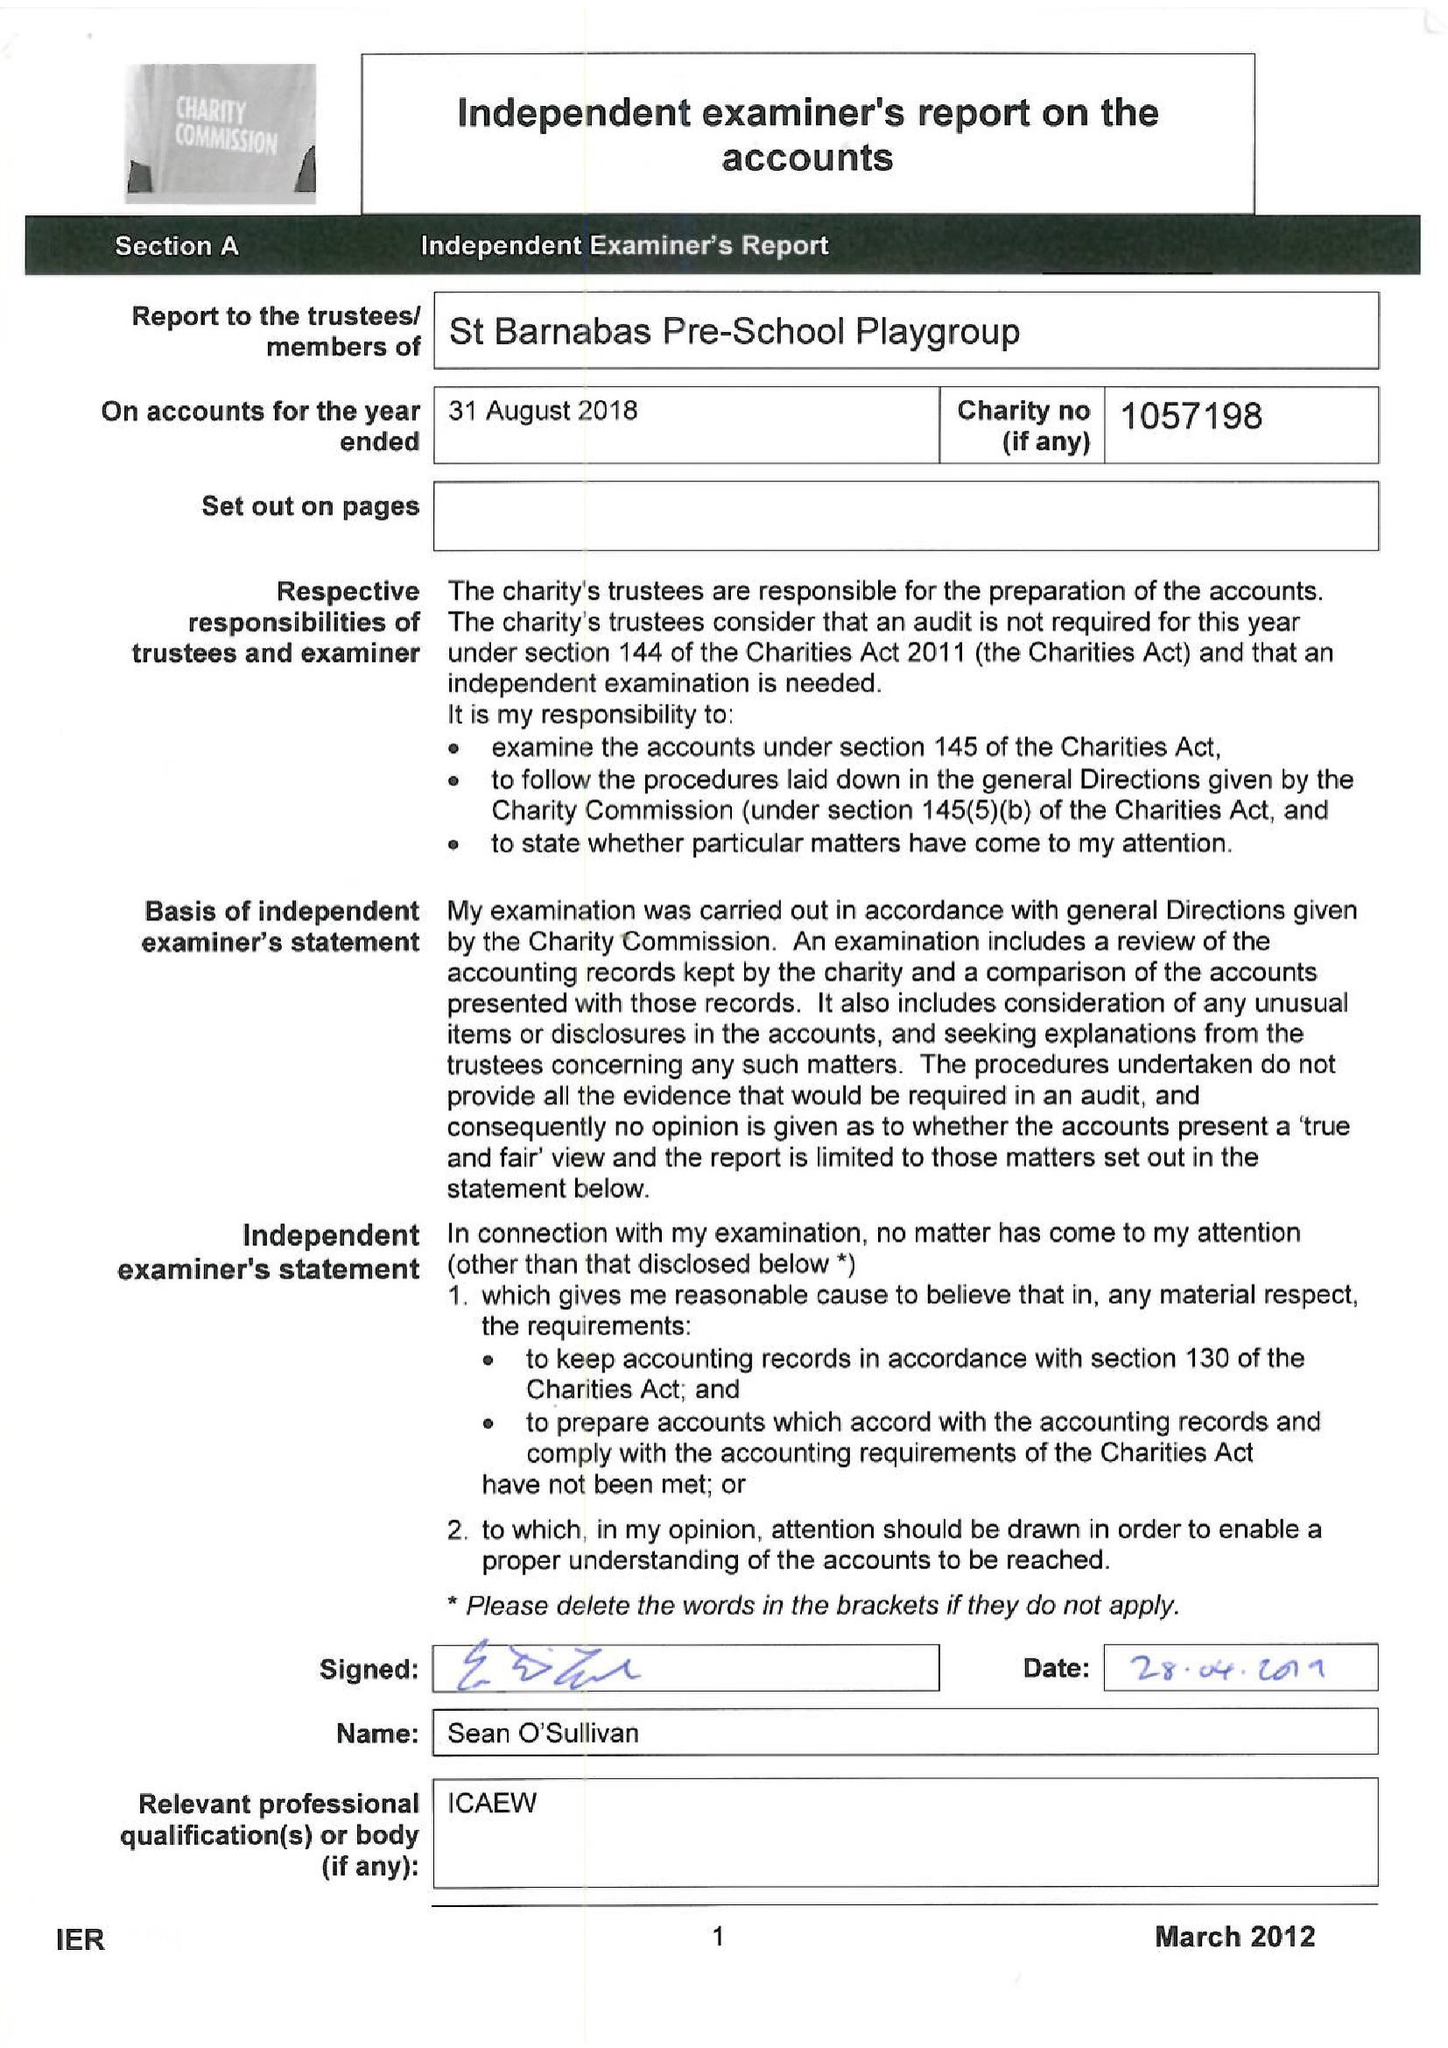What is the value for the charity_name?
Answer the question using a single word or phrase. St Barnabas Pre School Playgroup 